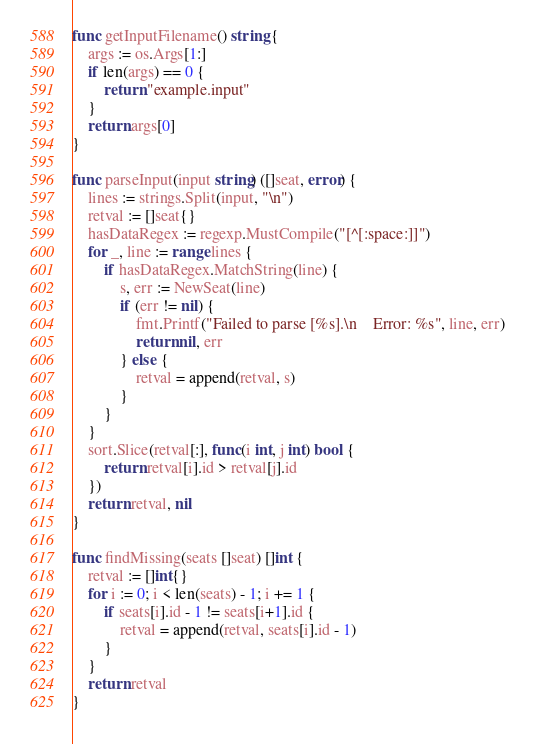Convert code to text. <code><loc_0><loc_0><loc_500><loc_500><_Go_>
func getInputFilename() string {
    args := os.Args[1:]
    if len(args) == 0 {
        return "example.input"
    }
    return args[0]
}

func parseInput(input string) ([]seat, error) {
    lines := strings.Split(input, "\n")
    retval := []seat{}
    hasDataRegex := regexp.MustCompile("[^[:space:]]")
    for _, line := range lines {
        if hasDataRegex.MatchString(line) {
            s, err := NewSeat(line)
            if (err != nil) {
                fmt.Printf("Failed to parse [%s].\n    Error: %s", line, err)
                return nil, err
            } else {
                retval = append(retval, s)
            }
        }
    }
    sort.Slice(retval[:], func(i int, j int) bool {
        return retval[i].id > retval[j].id
    })
    return retval, nil
}

func findMissing(seats []seat) []int {
    retval := []int{}
    for i := 0; i < len(seats) - 1; i += 1 {
        if seats[i].id - 1 != seats[i+1].id {
            retval = append(retval, seats[i].id - 1)
        }
    }
    return retval
}
</code> 